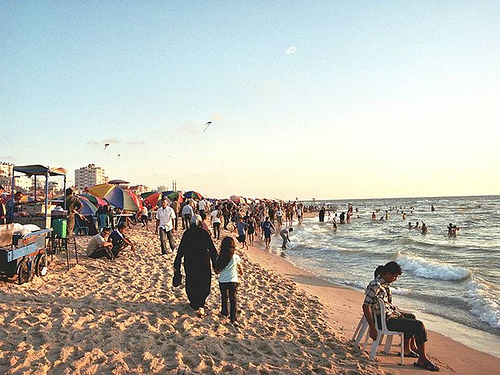Are there any pillows on the chair that is on the beach? There are no pillows on the chair; it's just an empty chair facing the ocean, providing a place to sit and enjoy the view. 